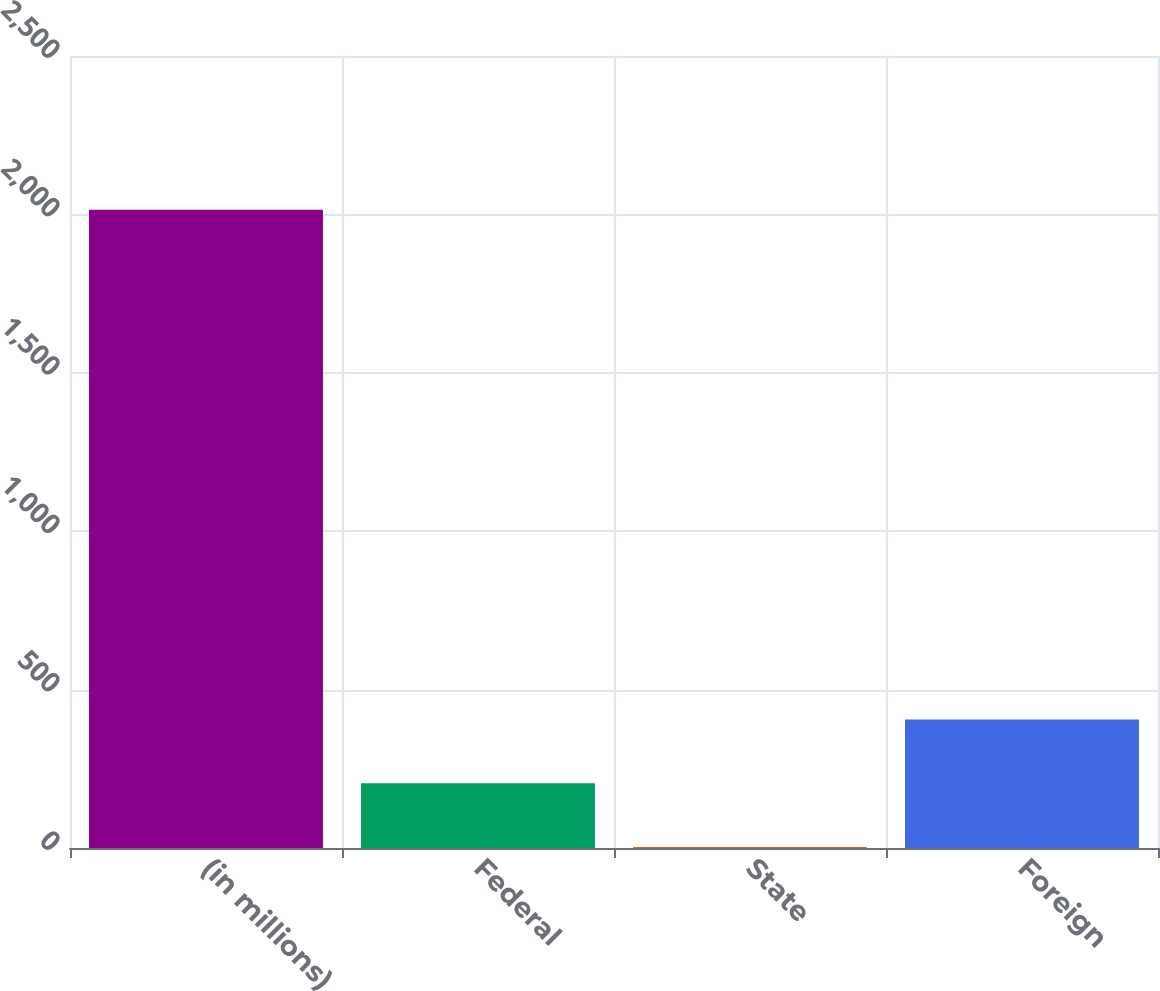Convert chart. <chart><loc_0><loc_0><loc_500><loc_500><bar_chart><fcel>(in millions)<fcel>Federal<fcel>State<fcel>Foreign<nl><fcel>2015<fcel>204.2<fcel>3<fcel>405.4<nl></chart> 